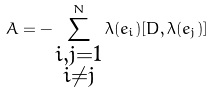<formula> <loc_0><loc_0><loc_500><loc_500>A = - \sum _ { \substack { i , j = 1 \\ i \neq j } } ^ { N } \lambda ( e _ { i } ) [ D , \lambda ( e _ { j } ) ]</formula> 